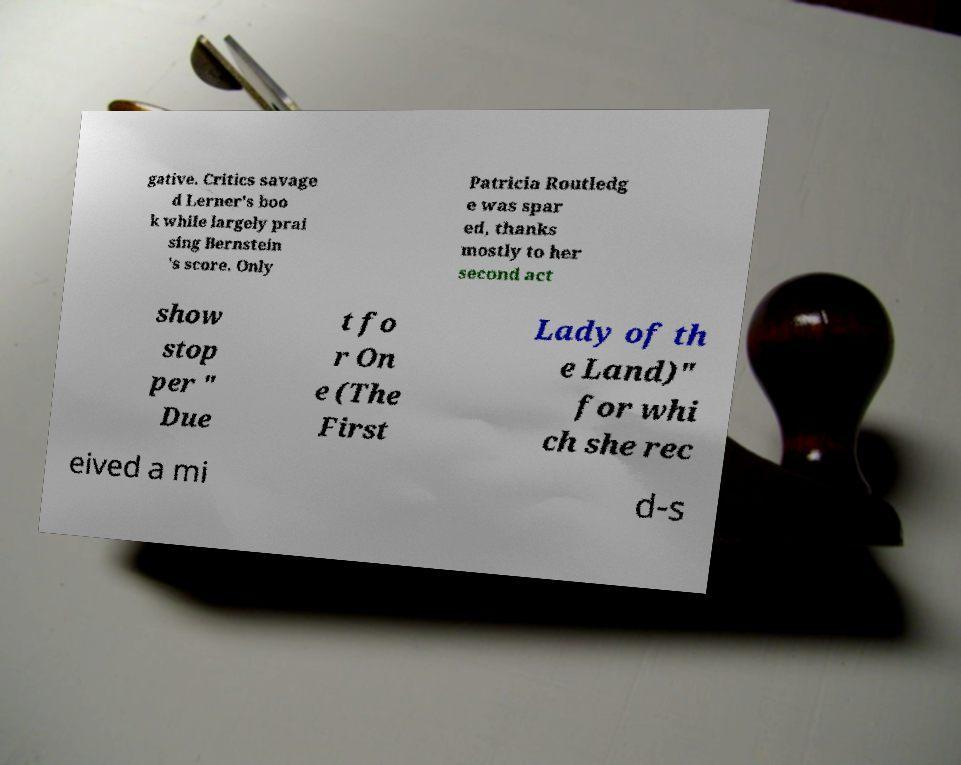For documentation purposes, I need the text within this image transcribed. Could you provide that? gative. Critics savage d Lerner's boo k while largely prai sing Bernstein 's score. Only Patricia Routledg e was spar ed, thanks mostly to her second act show stop per " Due t fo r On e (The First Lady of th e Land)" for whi ch she rec eived a mi d-s 